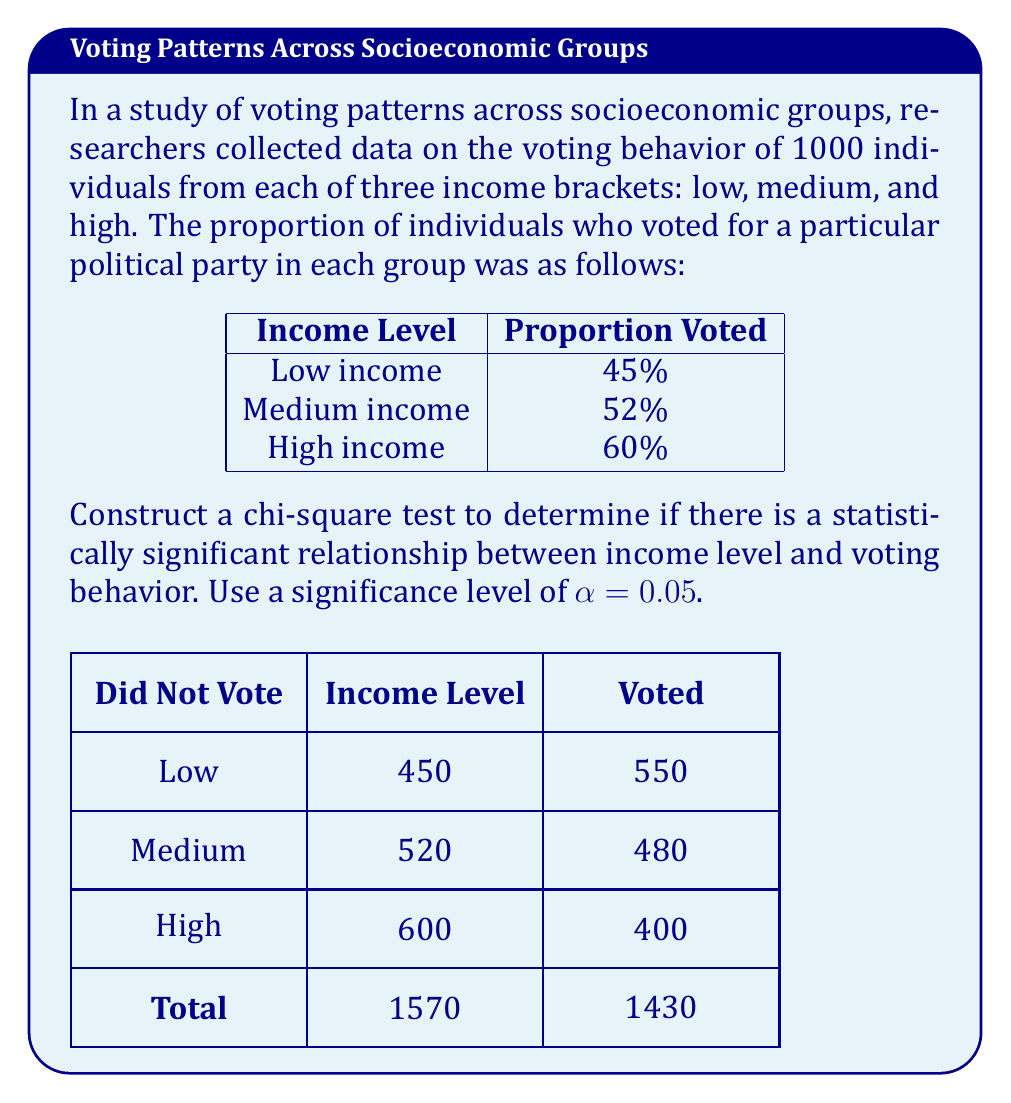Teach me how to tackle this problem. To perform a chi-square test for independence, we'll follow these steps:

1) First, let's set up our hypotheses:
   $H_0$: There is no relationship between income level and voting behavior
   $H_1$: There is a relationship between income level and voting behavior

2) Calculate the expected frequencies for each cell:
   Expected frequency = (row total × column total) ÷ grand total

   For "Voted" column:
   Low income: $(1000 × 1570) ÷ 3000 = 523.33$
   Medium income: $(1000 × 1570) ÷ 3000 = 523.33$
   High income: $(1000 × 1570) ÷ 3000 = 523.33$

   For "Did Not Vote" column:
   Low income: $(1000 × 1430) ÷ 3000 = 476.67$
   Medium income: $(1000 × 1430) ÷ 3000 = 476.67$
   High income: $(1000 × 1430) ÷ 3000 = 476.67$

3) Calculate the chi-square statistic:
   $$χ^2 = \sum \frac{(O - E)^2}{E}$$
   where O is the observed frequency and E is the expected frequency.

   $$χ^2 = \frac{(450 - 523.33)^2}{523.33} + \frac{(520 - 523.33)^2}{523.33} + \frac{(600 - 523.33)^2}{523.33} + $$
   $$\frac{(550 - 476.67)^2}{476.67} + \frac{(480 - 476.67)^2}{476.67} + \frac{(400 - 476.67)^2}{476.67}$$

   $$χ^2 = 10.33 + 0.02 + 11.22 + 11.35 + 0.02 + 12.33 = 45.27$$

4) Determine the degrees of freedom:
   df = (rows - 1) × (columns - 1) = (3 - 1) × (2 - 1) = 2

5) Find the critical value:
   For α = 0.05 and df = 2, the critical value is 5.991

6) Compare the calculated χ² value to the critical value:
   45.27 > 5.991

Therefore, we reject the null hypothesis. There is strong evidence to suggest a statistically significant relationship between income level and voting behavior.
Answer: Reject $H_0$; χ² = 45.27 > 5.991 (critical value) 